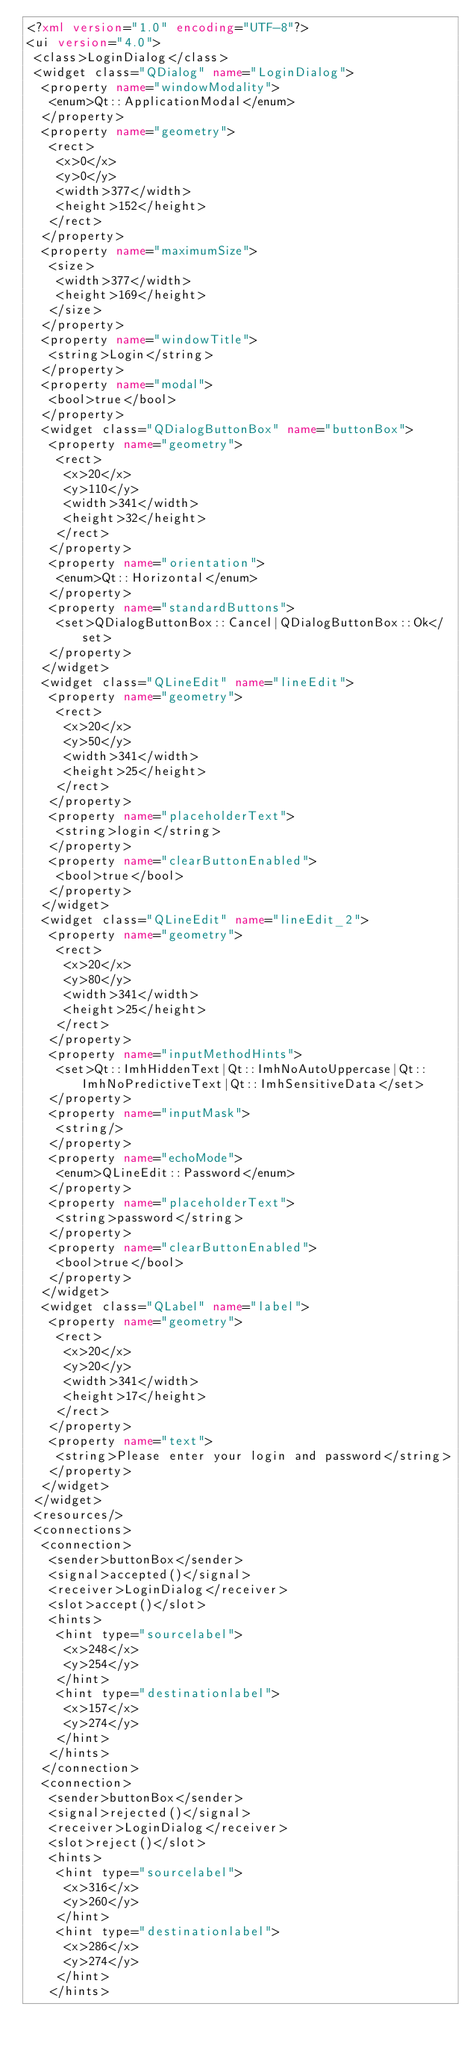Convert code to text. <code><loc_0><loc_0><loc_500><loc_500><_XML_><?xml version="1.0" encoding="UTF-8"?>
<ui version="4.0">
 <class>LoginDialog</class>
 <widget class="QDialog" name="LoginDialog">
  <property name="windowModality">
   <enum>Qt::ApplicationModal</enum>
  </property>
  <property name="geometry">
   <rect>
    <x>0</x>
    <y>0</y>
    <width>377</width>
    <height>152</height>
   </rect>
  </property>
  <property name="maximumSize">
   <size>
    <width>377</width>
    <height>169</height>
   </size>
  </property>
  <property name="windowTitle">
   <string>Login</string>
  </property>
  <property name="modal">
   <bool>true</bool>
  </property>
  <widget class="QDialogButtonBox" name="buttonBox">
   <property name="geometry">
    <rect>
     <x>20</x>
     <y>110</y>
     <width>341</width>
     <height>32</height>
    </rect>
   </property>
   <property name="orientation">
    <enum>Qt::Horizontal</enum>
   </property>
   <property name="standardButtons">
    <set>QDialogButtonBox::Cancel|QDialogButtonBox::Ok</set>
   </property>
  </widget>
  <widget class="QLineEdit" name="lineEdit">
   <property name="geometry">
    <rect>
     <x>20</x>
     <y>50</y>
     <width>341</width>
     <height>25</height>
    </rect>
   </property>
   <property name="placeholderText">
    <string>login</string>
   </property>
   <property name="clearButtonEnabled">
    <bool>true</bool>
   </property>
  </widget>
  <widget class="QLineEdit" name="lineEdit_2">
   <property name="geometry">
    <rect>
     <x>20</x>
     <y>80</y>
     <width>341</width>
     <height>25</height>
    </rect>
   </property>
   <property name="inputMethodHints">
    <set>Qt::ImhHiddenText|Qt::ImhNoAutoUppercase|Qt::ImhNoPredictiveText|Qt::ImhSensitiveData</set>
   </property>
   <property name="inputMask">
    <string/>
   </property>
   <property name="echoMode">
    <enum>QLineEdit::Password</enum>
   </property>
   <property name="placeholderText">
    <string>password</string>
   </property>
   <property name="clearButtonEnabled">
    <bool>true</bool>
   </property>
  </widget>
  <widget class="QLabel" name="label">
   <property name="geometry">
    <rect>
     <x>20</x>
     <y>20</y>
     <width>341</width>
     <height>17</height>
    </rect>
   </property>
   <property name="text">
    <string>Please enter your login and password</string>
   </property>
  </widget>
 </widget>
 <resources/>
 <connections>
  <connection>
   <sender>buttonBox</sender>
   <signal>accepted()</signal>
   <receiver>LoginDialog</receiver>
   <slot>accept()</slot>
   <hints>
    <hint type="sourcelabel">
     <x>248</x>
     <y>254</y>
    </hint>
    <hint type="destinationlabel">
     <x>157</x>
     <y>274</y>
    </hint>
   </hints>
  </connection>
  <connection>
   <sender>buttonBox</sender>
   <signal>rejected()</signal>
   <receiver>LoginDialog</receiver>
   <slot>reject()</slot>
   <hints>
    <hint type="sourcelabel">
     <x>316</x>
     <y>260</y>
    </hint>
    <hint type="destinationlabel">
     <x>286</x>
     <y>274</y>
    </hint>
   </hints></code> 